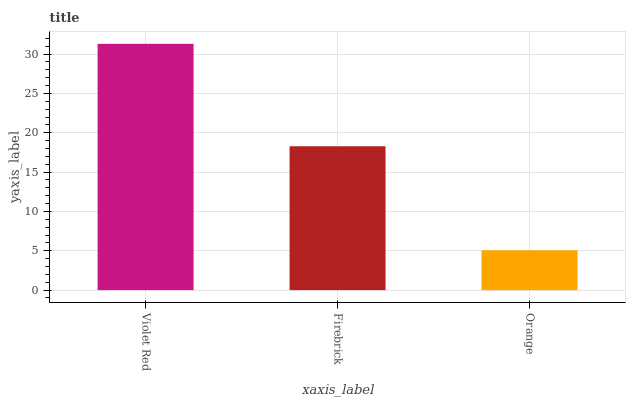Is Orange the minimum?
Answer yes or no. Yes. Is Violet Red the maximum?
Answer yes or no. Yes. Is Firebrick the minimum?
Answer yes or no. No. Is Firebrick the maximum?
Answer yes or no. No. Is Violet Red greater than Firebrick?
Answer yes or no. Yes. Is Firebrick less than Violet Red?
Answer yes or no. Yes. Is Firebrick greater than Violet Red?
Answer yes or no. No. Is Violet Red less than Firebrick?
Answer yes or no. No. Is Firebrick the high median?
Answer yes or no. Yes. Is Firebrick the low median?
Answer yes or no. Yes. Is Orange the high median?
Answer yes or no. No. Is Orange the low median?
Answer yes or no. No. 